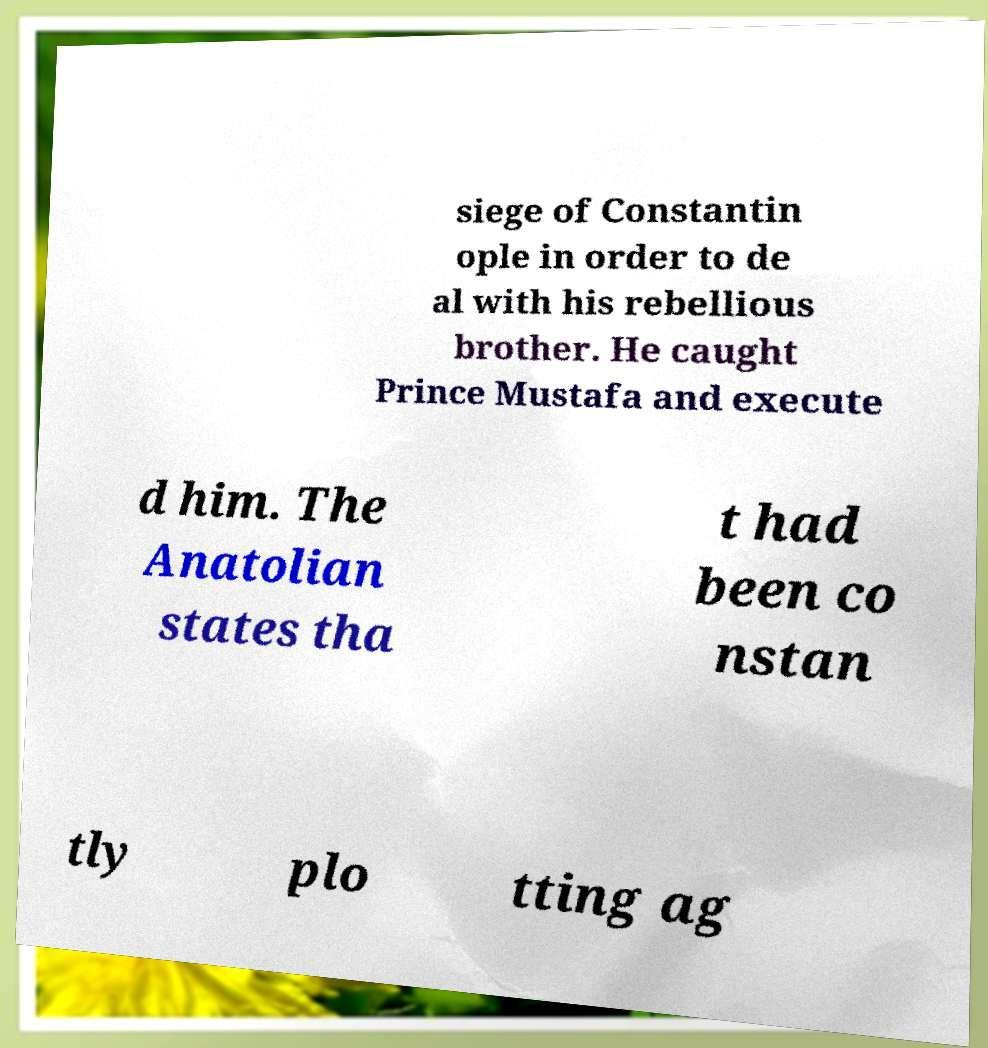Please read and relay the text visible in this image. What does it say? siege of Constantin ople in order to de al with his rebellious brother. He caught Prince Mustafa and execute d him. The Anatolian states tha t had been co nstan tly plo tting ag 